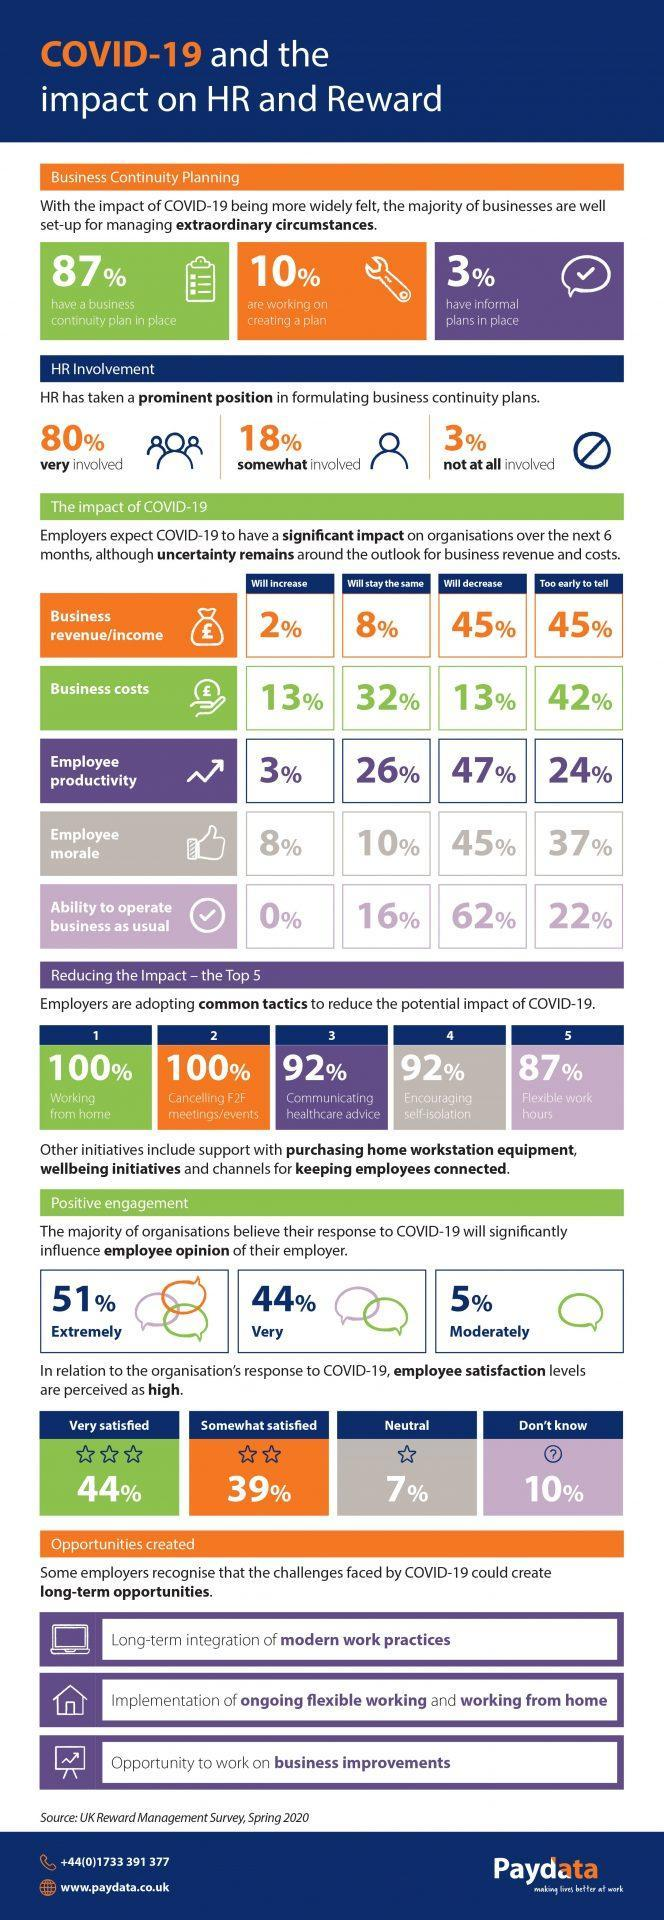How many of the employees are very satisfied with their organization's COVID-19 response?
Answer the question with a short phrase. 44% How many of the businesses have business continuity plan in place? 87% What is the opinion of 47% of employers regarding employee productivity? will decrease How many of the employers are adopting flexible work hours? 87% How many of the employers say that business costs will decrease? 13% In how many cases HR was very much involved in formulating business continuity plans? 80% What is the opinion of 32% of employers regarding business costs? will stay the same How many of the businesses are working on creating a plan? 10% How many of the employers are communicating healthcare advice with employees? 92% In how many cases HR was only somewhat involved in formulating business continuity plans? 18% 